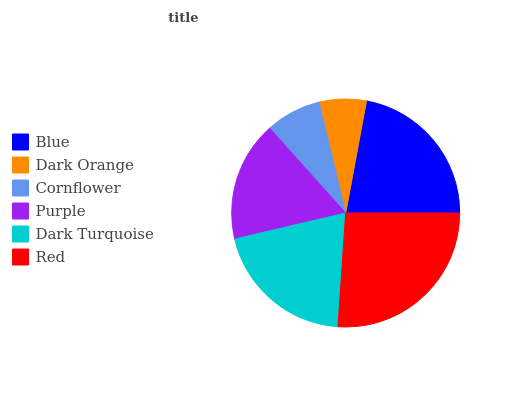Is Dark Orange the minimum?
Answer yes or no. Yes. Is Red the maximum?
Answer yes or no. Yes. Is Cornflower the minimum?
Answer yes or no. No. Is Cornflower the maximum?
Answer yes or no. No. Is Cornflower greater than Dark Orange?
Answer yes or no. Yes. Is Dark Orange less than Cornflower?
Answer yes or no. Yes. Is Dark Orange greater than Cornflower?
Answer yes or no. No. Is Cornflower less than Dark Orange?
Answer yes or no. No. Is Dark Turquoise the high median?
Answer yes or no. Yes. Is Purple the low median?
Answer yes or no. Yes. Is Blue the high median?
Answer yes or no. No. Is Dark Turquoise the low median?
Answer yes or no. No. 